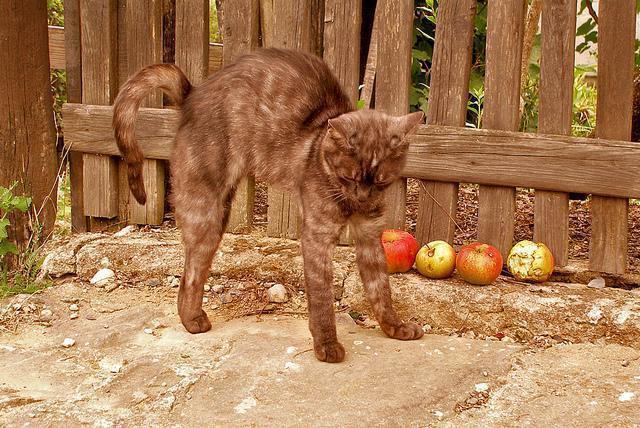What is the most popular type of apple?
Choose the right answer and clarify with the format: 'Answer: answer
Rationale: rationale.'
Options: Ladybug, honey crisp, red delicious, granny smith. Answer: red delicious.
Rationale: The red delicious apple is one that most people know. 